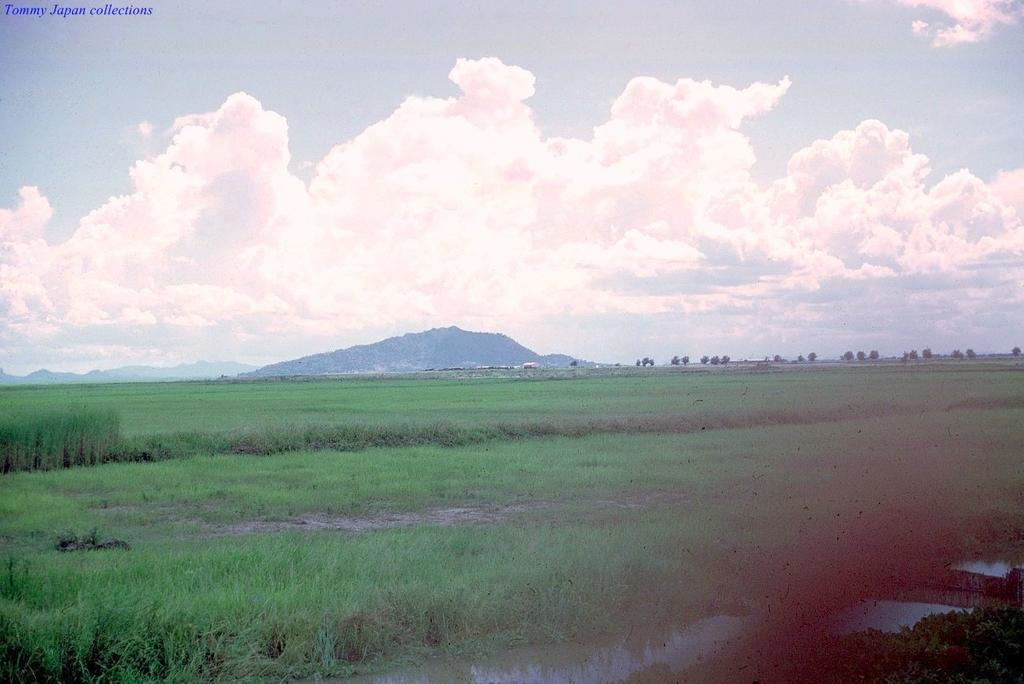What type of vegetation is present in the image? There is grass and plants in the image. What else can be seen in the image besides vegetation? There is water in the image. What can be seen in the background of the image? There are trees and clouds in the background of the image. What chance does the water have to affect the clouds in the image? The image does not depict any interaction between the water and clouds, so it is not possible to determine the chance of the water affecting the clouds. 